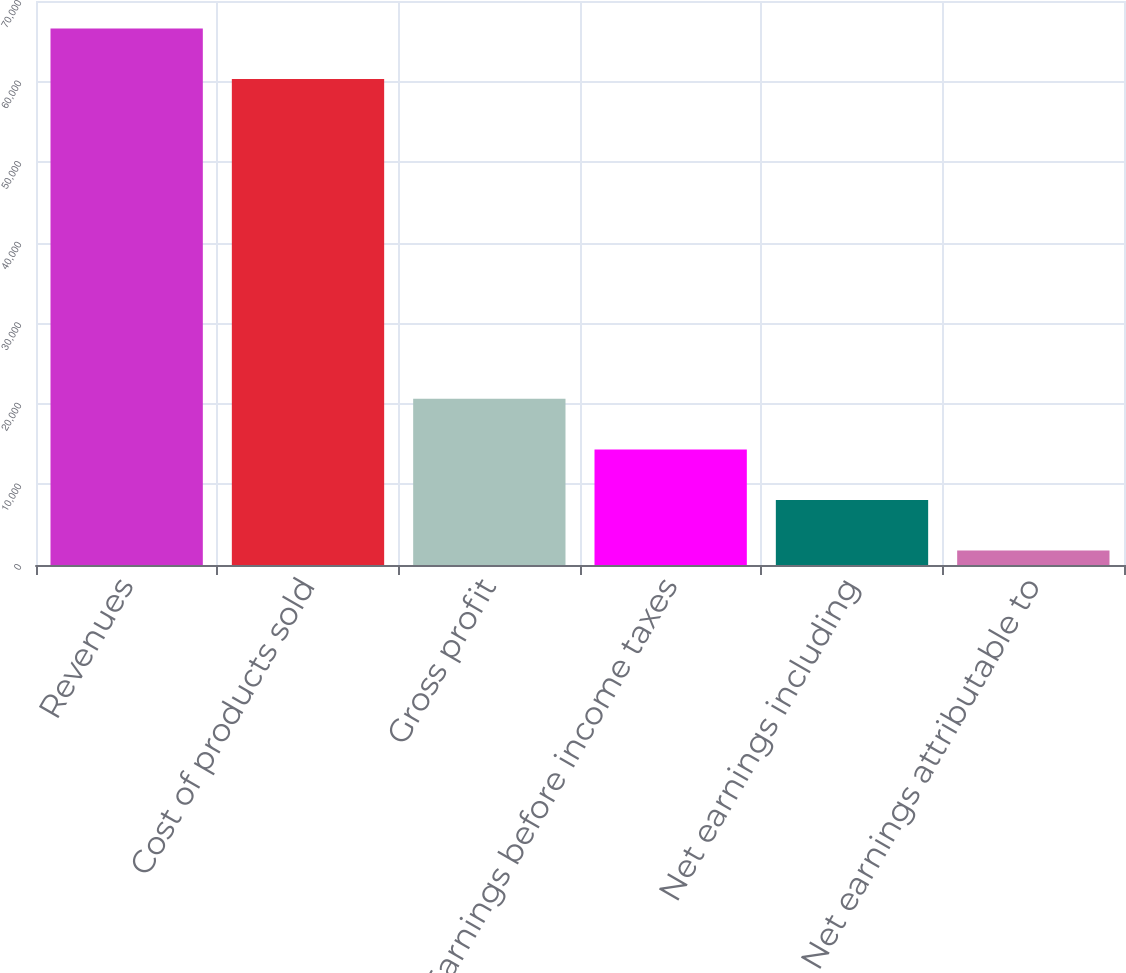<chart> <loc_0><loc_0><loc_500><loc_500><bar_chart><fcel>Revenues<fcel>Cost of products sold<fcel>Gross profit<fcel>Earnings before income taxes<fcel>Net earnings including<fcel>Net earnings attributable to<nl><fcel>66588<fcel>60319<fcel>20619<fcel>14350<fcel>8081<fcel>1812<nl></chart> 